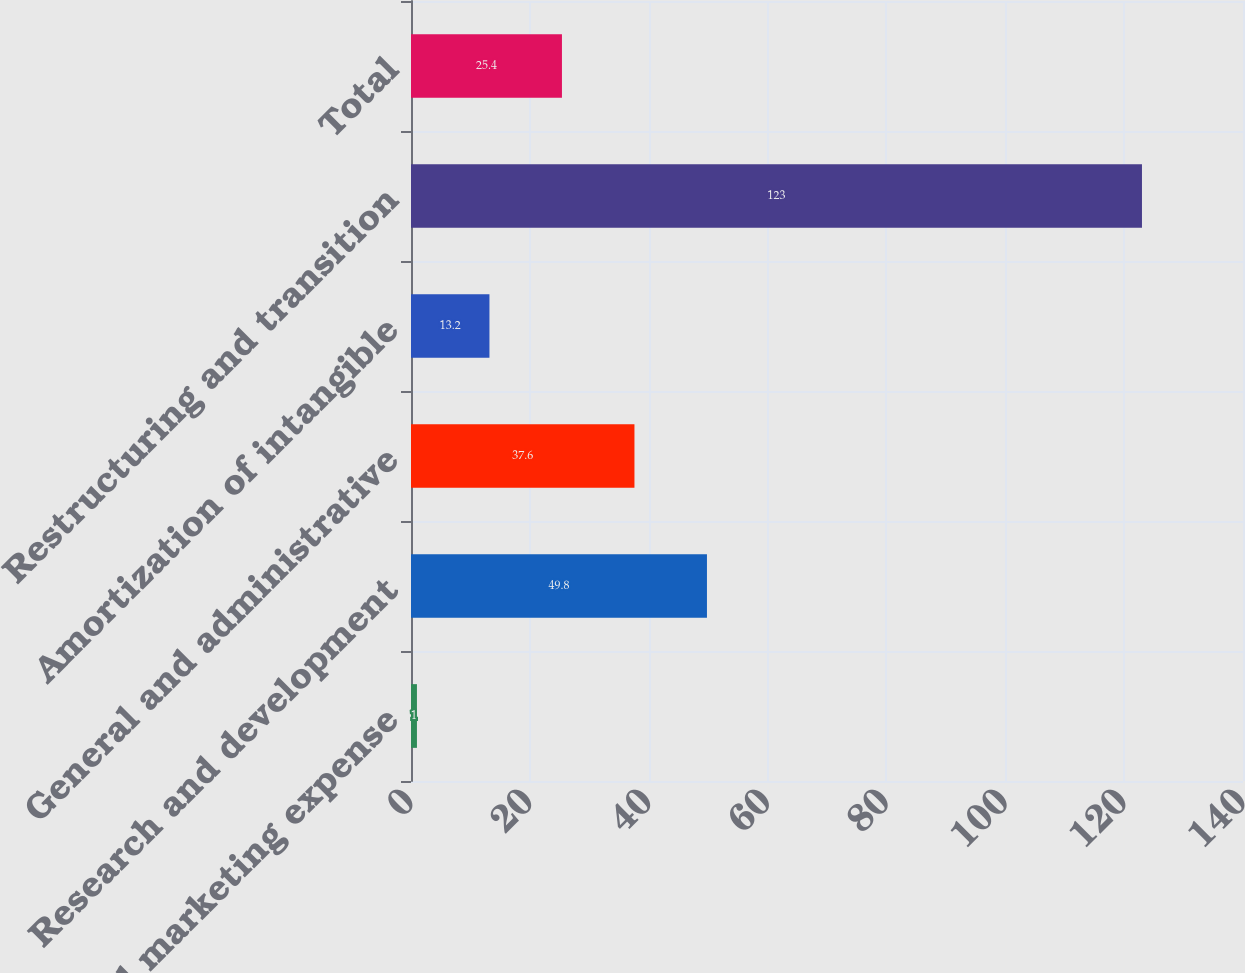Convert chart. <chart><loc_0><loc_0><loc_500><loc_500><bar_chart><fcel>Sales and marketing expense<fcel>Research and development<fcel>General and administrative<fcel>Amortization of intangible<fcel>Restructuring and transition<fcel>Total<nl><fcel>1<fcel>49.8<fcel>37.6<fcel>13.2<fcel>123<fcel>25.4<nl></chart> 